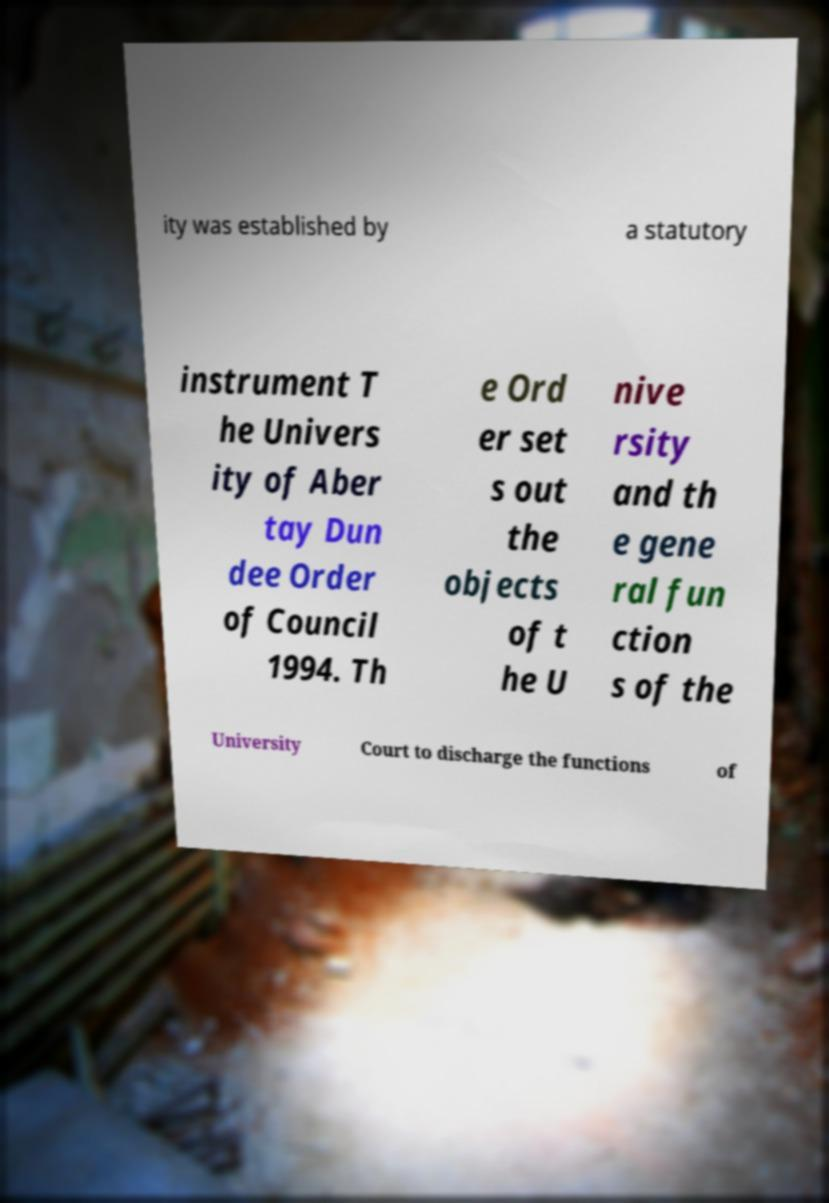Can you accurately transcribe the text from the provided image for me? ity was established by a statutory instrument T he Univers ity of Aber tay Dun dee Order of Council 1994. Th e Ord er set s out the objects of t he U nive rsity and th e gene ral fun ction s of the University Court to discharge the functions of 